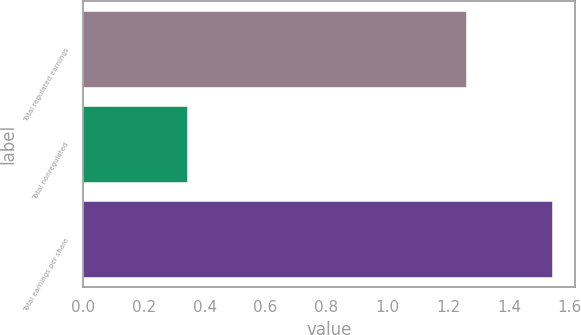Convert chart. <chart><loc_0><loc_0><loc_500><loc_500><bar_chart><fcel>Total regulated earnings<fcel>Total nonregulated<fcel>Total earnings per share<nl><fcel>1.26<fcel>0.34<fcel>1.54<nl></chart> 